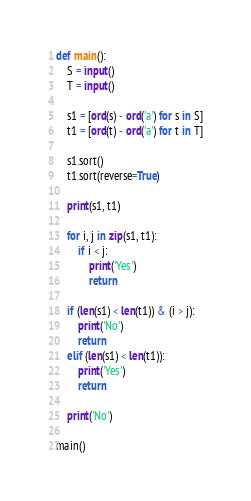<code> <loc_0><loc_0><loc_500><loc_500><_Python_>def main():
    S = input()
    T = input()

    s1 = [ord(s) - ord('a') for s in S]
    t1 = [ord(t) - ord('a') for t in T]

    s1.sort()
    t1.sort(reverse=True)

    print(s1, t1)

    for i, j in zip(s1, t1):
        if i < j:
            print('Yes')
            return

    if (len(s1) < len(t1)) & (i > j):
        print('No')
        return
    elif (len(s1) < len(t1)):
        print('Yes')
        return

    print('No')
    
main()</code> 